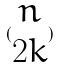<formula> <loc_0><loc_0><loc_500><loc_500>( \begin{matrix} n \\ 2 k \end{matrix} )</formula> 